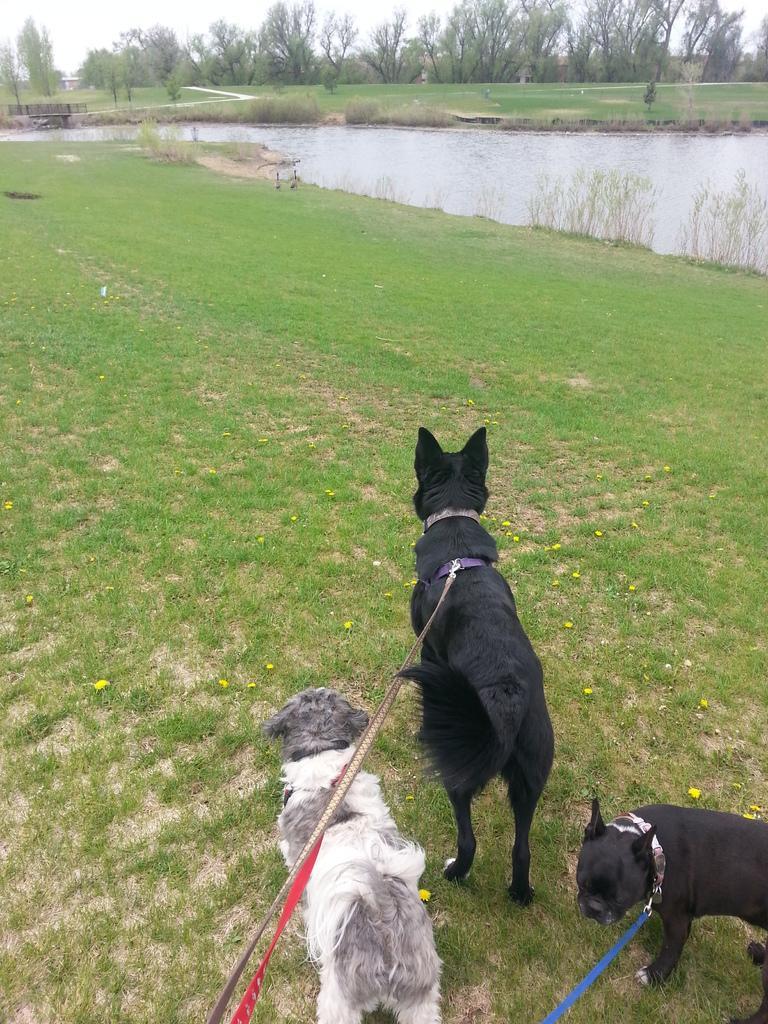Describe this image in one or two sentences. In this image there is grass at the bottom. There is an animal on the right corner. There are animals in the foreground. There are trees, there is water, there is grass in the background. And there is sky at the top. 